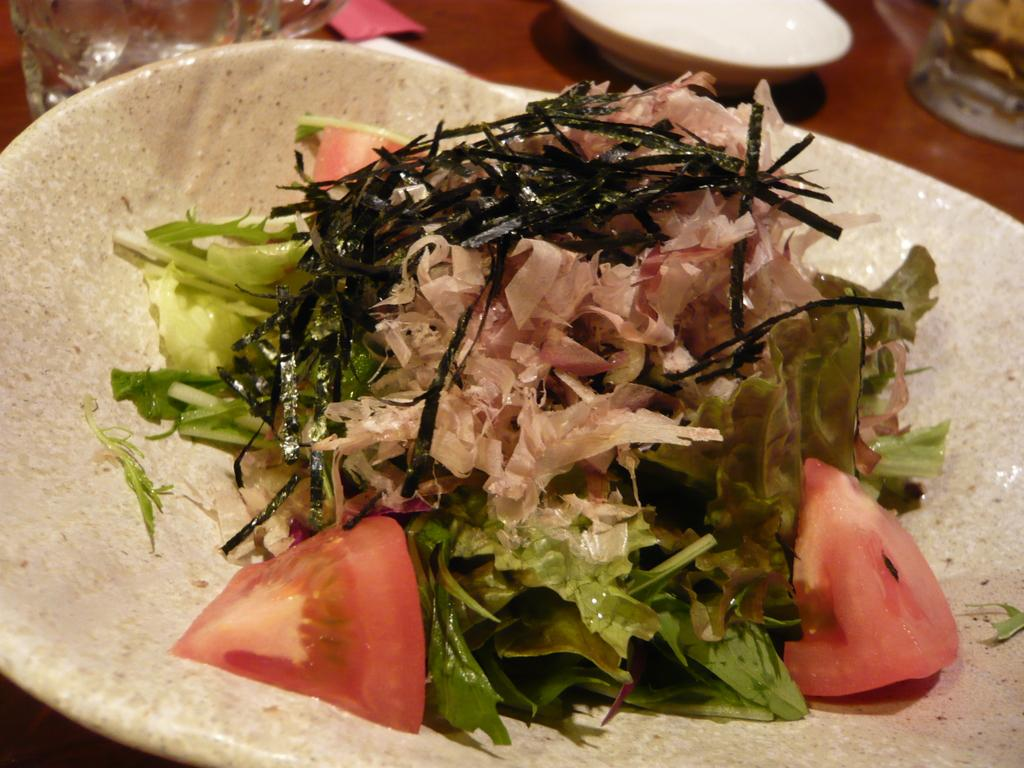What is on the plate that is visible in the image? There is food on a plate in the image. What type of dish is present in the image? There is a plate in the image. What other dish is present in the image besides the plate? There is a bowl in the image. What can be seen on the table in the image? There are glasses on the table in the image. What type of creature is playing the drum on the table in the image? There is no drum or creature present in the image. How does the head of the person in the image look like? There is no person or head visible in the image; it only shows food on a plate, a plate, a bowl, and glasses on a table. 